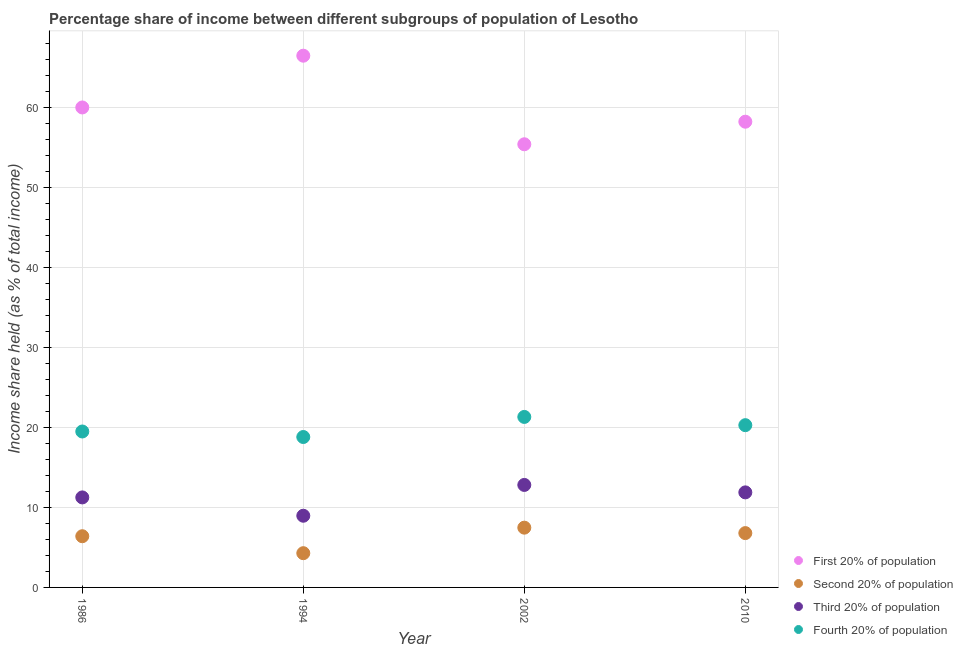How many different coloured dotlines are there?
Your answer should be very brief. 4. What is the share of the income held by fourth 20% of the population in 1986?
Make the answer very short. 19.49. Across all years, what is the maximum share of the income held by fourth 20% of the population?
Keep it short and to the point. 21.31. Across all years, what is the minimum share of the income held by third 20% of the population?
Provide a succinct answer. 8.96. In which year was the share of the income held by fourth 20% of the population minimum?
Keep it short and to the point. 1994. What is the total share of the income held by second 20% of the population in the graph?
Your response must be concise. 24.94. What is the difference between the share of the income held by fourth 20% of the population in 1986 and that in 1994?
Ensure brevity in your answer.  0.69. What is the difference between the share of the income held by fourth 20% of the population in 2002 and the share of the income held by second 20% of the population in 1986?
Make the answer very short. 14.91. What is the average share of the income held by fourth 20% of the population per year?
Offer a terse response. 19.97. In the year 1986, what is the difference between the share of the income held by third 20% of the population and share of the income held by fourth 20% of the population?
Keep it short and to the point. -8.24. In how many years, is the share of the income held by fourth 20% of the population greater than 52 %?
Keep it short and to the point. 0. What is the ratio of the share of the income held by second 20% of the population in 1994 to that in 2002?
Offer a very short reply. 0.57. Is the share of the income held by second 20% of the population in 1994 less than that in 2010?
Your answer should be very brief. Yes. Is the difference between the share of the income held by third 20% of the population in 1986 and 2002 greater than the difference between the share of the income held by fourth 20% of the population in 1986 and 2002?
Your response must be concise. Yes. What is the difference between the highest and the second highest share of the income held by third 20% of the population?
Your response must be concise. 0.93. What is the difference between the highest and the lowest share of the income held by third 20% of the population?
Your answer should be very brief. 3.85. Is it the case that in every year, the sum of the share of the income held by fourth 20% of the population and share of the income held by second 20% of the population is greater than the sum of share of the income held by first 20% of the population and share of the income held by third 20% of the population?
Ensure brevity in your answer.  No. Is it the case that in every year, the sum of the share of the income held by first 20% of the population and share of the income held by second 20% of the population is greater than the share of the income held by third 20% of the population?
Your answer should be very brief. Yes. Is the share of the income held by fourth 20% of the population strictly greater than the share of the income held by third 20% of the population over the years?
Your answer should be very brief. Yes. How many dotlines are there?
Keep it short and to the point. 4. How many years are there in the graph?
Give a very brief answer. 4. How many legend labels are there?
Ensure brevity in your answer.  4. How are the legend labels stacked?
Offer a terse response. Vertical. What is the title of the graph?
Ensure brevity in your answer.  Percentage share of income between different subgroups of population of Lesotho. Does "HFC gas" appear as one of the legend labels in the graph?
Your answer should be very brief. No. What is the label or title of the Y-axis?
Your answer should be compact. Income share held (as % of total income). What is the Income share held (as % of total income) in First 20% of population in 1986?
Offer a terse response. 59.99. What is the Income share held (as % of total income) of Second 20% of population in 1986?
Offer a terse response. 6.4. What is the Income share held (as % of total income) of Third 20% of population in 1986?
Provide a short and direct response. 11.25. What is the Income share held (as % of total income) of Fourth 20% of population in 1986?
Provide a short and direct response. 19.49. What is the Income share held (as % of total income) of First 20% of population in 1994?
Keep it short and to the point. 66.46. What is the Income share held (as % of total income) of Second 20% of population in 1994?
Provide a short and direct response. 4.28. What is the Income share held (as % of total income) in Third 20% of population in 1994?
Give a very brief answer. 8.96. What is the Income share held (as % of total income) in Fourth 20% of population in 1994?
Keep it short and to the point. 18.8. What is the Income share held (as % of total income) of First 20% of population in 2002?
Ensure brevity in your answer.  55.39. What is the Income share held (as % of total income) of Second 20% of population in 2002?
Your response must be concise. 7.47. What is the Income share held (as % of total income) in Third 20% of population in 2002?
Your answer should be very brief. 12.81. What is the Income share held (as % of total income) of Fourth 20% of population in 2002?
Keep it short and to the point. 21.31. What is the Income share held (as % of total income) in First 20% of population in 2010?
Provide a succinct answer. 58.21. What is the Income share held (as % of total income) in Second 20% of population in 2010?
Provide a short and direct response. 6.79. What is the Income share held (as % of total income) of Third 20% of population in 2010?
Provide a short and direct response. 11.88. What is the Income share held (as % of total income) in Fourth 20% of population in 2010?
Offer a terse response. 20.28. Across all years, what is the maximum Income share held (as % of total income) of First 20% of population?
Your answer should be compact. 66.46. Across all years, what is the maximum Income share held (as % of total income) of Second 20% of population?
Your response must be concise. 7.47. Across all years, what is the maximum Income share held (as % of total income) in Third 20% of population?
Your answer should be compact. 12.81. Across all years, what is the maximum Income share held (as % of total income) of Fourth 20% of population?
Keep it short and to the point. 21.31. Across all years, what is the minimum Income share held (as % of total income) in First 20% of population?
Provide a short and direct response. 55.39. Across all years, what is the minimum Income share held (as % of total income) of Second 20% of population?
Give a very brief answer. 4.28. Across all years, what is the minimum Income share held (as % of total income) in Third 20% of population?
Provide a succinct answer. 8.96. Across all years, what is the minimum Income share held (as % of total income) of Fourth 20% of population?
Ensure brevity in your answer.  18.8. What is the total Income share held (as % of total income) in First 20% of population in the graph?
Your answer should be compact. 240.05. What is the total Income share held (as % of total income) in Second 20% of population in the graph?
Give a very brief answer. 24.94. What is the total Income share held (as % of total income) in Third 20% of population in the graph?
Give a very brief answer. 44.9. What is the total Income share held (as % of total income) in Fourth 20% of population in the graph?
Offer a terse response. 79.88. What is the difference between the Income share held (as % of total income) of First 20% of population in 1986 and that in 1994?
Your answer should be very brief. -6.47. What is the difference between the Income share held (as % of total income) of Second 20% of population in 1986 and that in 1994?
Provide a short and direct response. 2.12. What is the difference between the Income share held (as % of total income) in Third 20% of population in 1986 and that in 1994?
Keep it short and to the point. 2.29. What is the difference between the Income share held (as % of total income) in Fourth 20% of population in 1986 and that in 1994?
Your answer should be compact. 0.69. What is the difference between the Income share held (as % of total income) of First 20% of population in 1986 and that in 2002?
Your answer should be very brief. 4.6. What is the difference between the Income share held (as % of total income) in Second 20% of population in 1986 and that in 2002?
Provide a short and direct response. -1.07. What is the difference between the Income share held (as % of total income) of Third 20% of population in 1986 and that in 2002?
Your response must be concise. -1.56. What is the difference between the Income share held (as % of total income) in Fourth 20% of population in 1986 and that in 2002?
Give a very brief answer. -1.82. What is the difference between the Income share held (as % of total income) of First 20% of population in 1986 and that in 2010?
Make the answer very short. 1.78. What is the difference between the Income share held (as % of total income) of Second 20% of population in 1986 and that in 2010?
Your answer should be very brief. -0.39. What is the difference between the Income share held (as % of total income) of Third 20% of population in 1986 and that in 2010?
Keep it short and to the point. -0.63. What is the difference between the Income share held (as % of total income) in Fourth 20% of population in 1986 and that in 2010?
Provide a succinct answer. -0.79. What is the difference between the Income share held (as % of total income) of First 20% of population in 1994 and that in 2002?
Your answer should be compact. 11.07. What is the difference between the Income share held (as % of total income) of Second 20% of population in 1994 and that in 2002?
Make the answer very short. -3.19. What is the difference between the Income share held (as % of total income) of Third 20% of population in 1994 and that in 2002?
Your answer should be compact. -3.85. What is the difference between the Income share held (as % of total income) of Fourth 20% of population in 1994 and that in 2002?
Make the answer very short. -2.51. What is the difference between the Income share held (as % of total income) in First 20% of population in 1994 and that in 2010?
Your answer should be compact. 8.25. What is the difference between the Income share held (as % of total income) of Second 20% of population in 1994 and that in 2010?
Provide a succinct answer. -2.51. What is the difference between the Income share held (as % of total income) in Third 20% of population in 1994 and that in 2010?
Make the answer very short. -2.92. What is the difference between the Income share held (as % of total income) in Fourth 20% of population in 1994 and that in 2010?
Offer a terse response. -1.48. What is the difference between the Income share held (as % of total income) of First 20% of population in 2002 and that in 2010?
Ensure brevity in your answer.  -2.82. What is the difference between the Income share held (as % of total income) in Second 20% of population in 2002 and that in 2010?
Ensure brevity in your answer.  0.68. What is the difference between the Income share held (as % of total income) of Third 20% of population in 2002 and that in 2010?
Your answer should be very brief. 0.93. What is the difference between the Income share held (as % of total income) in Fourth 20% of population in 2002 and that in 2010?
Make the answer very short. 1.03. What is the difference between the Income share held (as % of total income) of First 20% of population in 1986 and the Income share held (as % of total income) of Second 20% of population in 1994?
Give a very brief answer. 55.71. What is the difference between the Income share held (as % of total income) in First 20% of population in 1986 and the Income share held (as % of total income) in Third 20% of population in 1994?
Keep it short and to the point. 51.03. What is the difference between the Income share held (as % of total income) in First 20% of population in 1986 and the Income share held (as % of total income) in Fourth 20% of population in 1994?
Offer a very short reply. 41.19. What is the difference between the Income share held (as % of total income) in Second 20% of population in 1986 and the Income share held (as % of total income) in Third 20% of population in 1994?
Your response must be concise. -2.56. What is the difference between the Income share held (as % of total income) of Second 20% of population in 1986 and the Income share held (as % of total income) of Fourth 20% of population in 1994?
Your answer should be compact. -12.4. What is the difference between the Income share held (as % of total income) of Third 20% of population in 1986 and the Income share held (as % of total income) of Fourth 20% of population in 1994?
Your answer should be compact. -7.55. What is the difference between the Income share held (as % of total income) of First 20% of population in 1986 and the Income share held (as % of total income) of Second 20% of population in 2002?
Give a very brief answer. 52.52. What is the difference between the Income share held (as % of total income) of First 20% of population in 1986 and the Income share held (as % of total income) of Third 20% of population in 2002?
Your response must be concise. 47.18. What is the difference between the Income share held (as % of total income) of First 20% of population in 1986 and the Income share held (as % of total income) of Fourth 20% of population in 2002?
Offer a very short reply. 38.68. What is the difference between the Income share held (as % of total income) in Second 20% of population in 1986 and the Income share held (as % of total income) in Third 20% of population in 2002?
Offer a terse response. -6.41. What is the difference between the Income share held (as % of total income) in Second 20% of population in 1986 and the Income share held (as % of total income) in Fourth 20% of population in 2002?
Your response must be concise. -14.91. What is the difference between the Income share held (as % of total income) of Third 20% of population in 1986 and the Income share held (as % of total income) of Fourth 20% of population in 2002?
Your response must be concise. -10.06. What is the difference between the Income share held (as % of total income) of First 20% of population in 1986 and the Income share held (as % of total income) of Second 20% of population in 2010?
Your response must be concise. 53.2. What is the difference between the Income share held (as % of total income) in First 20% of population in 1986 and the Income share held (as % of total income) in Third 20% of population in 2010?
Your answer should be compact. 48.11. What is the difference between the Income share held (as % of total income) of First 20% of population in 1986 and the Income share held (as % of total income) of Fourth 20% of population in 2010?
Keep it short and to the point. 39.71. What is the difference between the Income share held (as % of total income) in Second 20% of population in 1986 and the Income share held (as % of total income) in Third 20% of population in 2010?
Keep it short and to the point. -5.48. What is the difference between the Income share held (as % of total income) in Second 20% of population in 1986 and the Income share held (as % of total income) in Fourth 20% of population in 2010?
Ensure brevity in your answer.  -13.88. What is the difference between the Income share held (as % of total income) of Third 20% of population in 1986 and the Income share held (as % of total income) of Fourth 20% of population in 2010?
Your answer should be compact. -9.03. What is the difference between the Income share held (as % of total income) of First 20% of population in 1994 and the Income share held (as % of total income) of Second 20% of population in 2002?
Make the answer very short. 58.99. What is the difference between the Income share held (as % of total income) in First 20% of population in 1994 and the Income share held (as % of total income) in Third 20% of population in 2002?
Ensure brevity in your answer.  53.65. What is the difference between the Income share held (as % of total income) in First 20% of population in 1994 and the Income share held (as % of total income) in Fourth 20% of population in 2002?
Provide a short and direct response. 45.15. What is the difference between the Income share held (as % of total income) in Second 20% of population in 1994 and the Income share held (as % of total income) in Third 20% of population in 2002?
Offer a very short reply. -8.53. What is the difference between the Income share held (as % of total income) of Second 20% of population in 1994 and the Income share held (as % of total income) of Fourth 20% of population in 2002?
Make the answer very short. -17.03. What is the difference between the Income share held (as % of total income) in Third 20% of population in 1994 and the Income share held (as % of total income) in Fourth 20% of population in 2002?
Make the answer very short. -12.35. What is the difference between the Income share held (as % of total income) in First 20% of population in 1994 and the Income share held (as % of total income) in Second 20% of population in 2010?
Offer a very short reply. 59.67. What is the difference between the Income share held (as % of total income) in First 20% of population in 1994 and the Income share held (as % of total income) in Third 20% of population in 2010?
Make the answer very short. 54.58. What is the difference between the Income share held (as % of total income) in First 20% of population in 1994 and the Income share held (as % of total income) in Fourth 20% of population in 2010?
Give a very brief answer. 46.18. What is the difference between the Income share held (as % of total income) in Second 20% of population in 1994 and the Income share held (as % of total income) in Fourth 20% of population in 2010?
Provide a succinct answer. -16. What is the difference between the Income share held (as % of total income) in Third 20% of population in 1994 and the Income share held (as % of total income) in Fourth 20% of population in 2010?
Offer a very short reply. -11.32. What is the difference between the Income share held (as % of total income) in First 20% of population in 2002 and the Income share held (as % of total income) in Second 20% of population in 2010?
Give a very brief answer. 48.6. What is the difference between the Income share held (as % of total income) in First 20% of population in 2002 and the Income share held (as % of total income) in Third 20% of population in 2010?
Provide a succinct answer. 43.51. What is the difference between the Income share held (as % of total income) of First 20% of population in 2002 and the Income share held (as % of total income) of Fourth 20% of population in 2010?
Provide a short and direct response. 35.11. What is the difference between the Income share held (as % of total income) of Second 20% of population in 2002 and the Income share held (as % of total income) of Third 20% of population in 2010?
Offer a terse response. -4.41. What is the difference between the Income share held (as % of total income) in Second 20% of population in 2002 and the Income share held (as % of total income) in Fourth 20% of population in 2010?
Your answer should be very brief. -12.81. What is the difference between the Income share held (as % of total income) of Third 20% of population in 2002 and the Income share held (as % of total income) of Fourth 20% of population in 2010?
Offer a very short reply. -7.47. What is the average Income share held (as % of total income) of First 20% of population per year?
Your answer should be very brief. 60.01. What is the average Income share held (as % of total income) of Second 20% of population per year?
Ensure brevity in your answer.  6.24. What is the average Income share held (as % of total income) of Third 20% of population per year?
Your answer should be compact. 11.22. What is the average Income share held (as % of total income) of Fourth 20% of population per year?
Your response must be concise. 19.97. In the year 1986, what is the difference between the Income share held (as % of total income) in First 20% of population and Income share held (as % of total income) in Second 20% of population?
Keep it short and to the point. 53.59. In the year 1986, what is the difference between the Income share held (as % of total income) in First 20% of population and Income share held (as % of total income) in Third 20% of population?
Your answer should be very brief. 48.74. In the year 1986, what is the difference between the Income share held (as % of total income) in First 20% of population and Income share held (as % of total income) in Fourth 20% of population?
Provide a succinct answer. 40.5. In the year 1986, what is the difference between the Income share held (as % of total income) in Second 20% of population and Income share held (as % of total income) in Third 20% of population?
Give a very brief answer. -4.85. In the year 1986, what is the difference between the Income share held (as % of total income) in Second 20% of population and Income share held (as % of total income) in Fourth 20% of population?
Ensure brevity in your answer.  -13.09. In the year 1986, what is the difference between the Income share held (as % of total income) in Third 20% of population and Income share held (as % of total income) in Fourth 20% of population?
Provide a succinct answer. -8.24. In the year 1994, what is the difference between the Income share held (as % of total income) in First 20% of population and Income share held (as % of total income) in Second 20% of population?
Keep it short and to the point. 62.18. In the year 1994, what is the difference between the Income share held (as % of total income) in First 20% of population and Income share held (as % of total income) in Third 20% of population?
Your answer should be compact. 57.5. In the year 1994, what is the difference between the Income share held (as % of total income) in First 20% of population and Income share held (as % of total income) in Fourth 20% of population?
Give a very brief answer. 47.66. In the year 1994, what is the difference between the Income share held (as % of total income) of Second 20% of population and Income share held (as % of total income) of Third 20% of population?
Offer a very short reply. -4.68. In the year 1994, what is the difference between the Income share held (as % of total income) in Second 20% of population and Income share held (as % of total income) in Fourth 20% of population?
Give a very brief answer. -14.52. In the year 1994, what is the difference between the Income share held (as % of total income) of Third 20% of population and Income share held (as % of total income) of Fourth 20% of population?
Your answer should be compact. -9.84. In the year 2002, what is the difference between the Income share held (as % of total income) in First 20% of population and Income share held (as % of total income) in Second 20% of population?
Your answer should be very brief. 47.92. In the year 2002, what is the difference between the Income share held (as % of total income) in First 20% of population and Income share held (as % of total income) in Third 20% of population?
Your response must be concise. 42.58. In the year 2002, what is the difference between the Income share held (as % of total income) in First 20% of population and Income share held (as % of total income) in Fourth 20% of population?
Your response must be concise. 34.08. In the year 2002, what is the difference between the Income share held (as % of total income) in Second 20% of population and Income share held (as % of total income) in Third 20% of population?
Offer a very short reply. -5.34. In the year 2002, what is the difference between the Income share held (as % of total income) of Second 20% of population and Income share held (as % of total income) of Fourth 20% of population?
Ensure brevity in your answer.  -13.84. In the year 2010, what is the difference between the Income share held (as % of total income) of First 20% of population and Income share held (as % of total income) of Second 20% of population?
Ensure brevity in your answer.  51.42. In the year 2010, what is the difference between the Income share held (as % of total income) in First 20% of population and Income share held (as % of total income) in Third 20% of population?
Ensure brevity in your answer.  46.33. In the year 2010, what is the difference between the Income share held (as % of total income) of First 20% of population and Income share held (as % of total income) of Fourth 20% of population?
Provide a short and direct response. 37.93. In the year 2010, what is the difference between the Income share held (as % of total income) of Second 20% of population and Income share held (as % of total income) of Third 20% of population?
Provide a succinct answer. -5.09. In the year 2010, what is the difference between the Income share held (as % of total income) of Second 20% of population and Income share held (as % of total income) of Fourth 20% of population?
Your response must be concise. -13.49. In the year 2010, what is the difference between the Income share held (as % of total income) in Third 20% of population and Income share held (as % of total income) in Fourth 20% of population?
Your response must be concise. -8.4. What is the ratio of the Income share held (as % of total income) of First 20% of population in 1986 to that in 1994?
Your answer should be very brief. 0.9. What is the ratio of the Income share held (as % of total income) of Second 20% of population in 1986 to that in 1994?
Provide a succinct answer. 1.5. What is the ratio of the Income share held (as % of total income) in Third 20% of population in 1986 to that in 1994?
Offer a terse response. 1.26. What is the ratio of the Income share held (as % of total income) of Fourth 20% of population in 1986 to that in 1994?
Your answer should be very brief. 1.04. What is the ratio of the Income share held (as % of total income) in First 20% of population in 1986 to that in 2002?
Give a very brief answer. 1.08. What is the ratio of the Income share held (as % of total income) in Second 20% of population in 1986 to that in 2002?
Your response must be concise. 0.86. What is the ratio of the Income share held (as % of total income) in Third 20% of population in 1986 to that in 2002?
Make the answer very short. 0.88. What is the ratio of the Income share held (as % of total income) in Fourth 20% of population in 1986 to that in 2002?
Make the answer very short. 0.91. What is the ratio of the Income share held (as % of total income) in First 20% of population in 1986 to that in 2010?
Provide a succinct answer. 1.03. What is the ratio of the Income share held (as % of total income) in Second 20% of population in 1986 to that in 2010?
Provide a short and direct response. 0.94. What is the ratio of the Income share held (as % of total income) in Third 20% of population in 1986 to that in 2010?
Give a very brief answer. 0.95. What is the ratio of the Income share held (as % of total income) of Fourth 20% of population in 1986 to that in 2010?
Offer a very short reply. 0.96. What is the ratio of the Income share held (as % of total income) in First 20% of population in 1994 to that in 2002?
Your response must be concise. 1.2. What is the ratio of the Income share held (as % of total income) in Second 20% of population in 1994 to that in 2002?
Keep it short and to the point. 0.57. What is the ratio of the Income share held (as % of total income) in Third 20% of population in 1994 to that in 2002?
Keep it short and to the point. 0.7. What is the ratio of the Income share held (as % of total income) of Fourth 20% of population in 1994 to that in 2002?
Ensure brevity in your answer.  0.88. What is the ratio of the Income share held (as % of total income) of First 20% of population in 1994 to that in 2010?
Your answer should be very brief. 1.14. What is the ratio of the Income share held (as % of total income) in Second 20% of population in 1994 to that in 2010?
Your answer should be very brief. 0.63. What is the ratio of the Income share held (as % of total income) of Third 20% of population in 1994 to that in 2010?
Offer a terse response. 0.75. What is the ratio of the Income share held (as % of total income) in Fourth 20% of population in 1994 to that in 2010?
Give a very brief answer. 0.93. What is the ratio of the Income share held (as % of total income) of First 20% of population in 2002 to that in 2010?
Provide a short and direct response. 0.95. What is the ratio of the Income share held (as % of total income) in Second 20% of population in 2002 to that in 2010?
Keep it short and to the point. 1.1. What is the ratio of the Income share held (as % of total income) in Third 20% of population in 2002 to that in 2010?
Your response must be concise. 1.08. What is the ratio of the Income share held (as % of total income) of Fourth 20% of population in 2002 to that in 2010?
Your response must be concise. 1.05. What is the difference between the highest and the second highest Income share held (as % of total income) in First 20% of population?
Offer a terse response. 6.47. What is the difference between the highest and the second highest Income share held (as % of total income) in Second 20% of population?
Your response must be concise. 0.68. What is the difference between the highest and the second highest Income share held (as % of total income) of Fourth 20% of population?
Keep it short and to the point. 1.03. What is the difference between the highest and the lowest Income share held (as % of total income) in First 20% of population?
Keep it short and to the point. 11.07. What is the difference between the highest and the lowest Income share held (as % of total income) of Second 20% of population?
Provide a succinct answer. 3.19. What is the difference between the highest and the lowest Income share held (as % of total income) of Third 20% of population?
Provide a succinct answer. 3.85. What is the difference between the highest and the lowest Income share held (as % of total income) in Fourth 20% of population?
Keep it short and to the point. 2.51. 